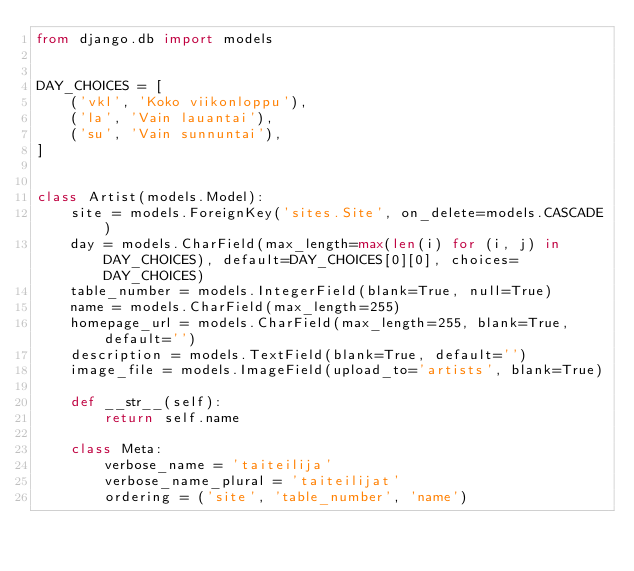<code> <loc_0><loc_0><loc_500><loc_500><_Python_>from django.db import models


DAY_CHOICES = [
    ('vkl', 'Koko viikonloppu'),
    ('la', 'Vain lauantai'),
    ('su', 'Vain sunnuntai'),
]


class Artist(models.Model):
    site = models.ForeignKey('sites.Site', on_delete=models.CASCADE)
    day = models.CharField(max_length=max(len(i) for (i, j) in DAY_CHOICES), default=DAY_CHOICES[0][0], choices=DAY_CHOICES)
    table_number = models.IntegerField(blank=True, null=True)
    name = models.CharField(max_length=255)
    homepage_url = models.CharField(max_length=255, blank=True, default='')
    description = models.TextField(blank=True, default='')
    image_file = models.ImageField(upload_to='artists', blank=True)

    def __str__(self):
        return self.name

    class Meta:
        verbose_name = 'taiteilija'
        verbose_name_plural = 'taiteilijat'
        ordering = ('site', 'table_number', 'name')
</code> 